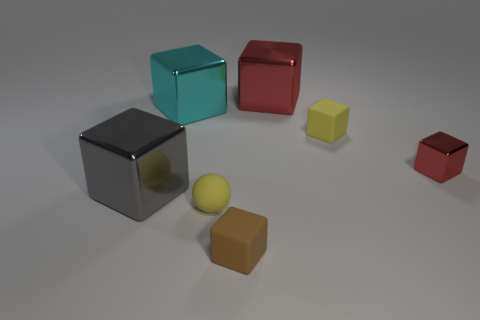Subtract all brown cubes. How many cubes are left? 5 Subtract all cyan blocks. How many blocks are left? 5 Subtract 2 blocks. How many blocks are left? 4 Subtract all green cubes. Subtract all red cylinders. How many cubes are left? 6 Add 1 small red things. How many objects exist? 8 Subtract all spheres. How many objects are left? 6 Subtract all big gray metal blocks. Subtract all small gray matte things. How many objects are left? 6 Add 1 big red objects. How many big red objects are left? 2 Add 2 large blue rubber things. How many large blue rubber things exist? 2 Subtract 0 green balls. How many objects are left? 7 